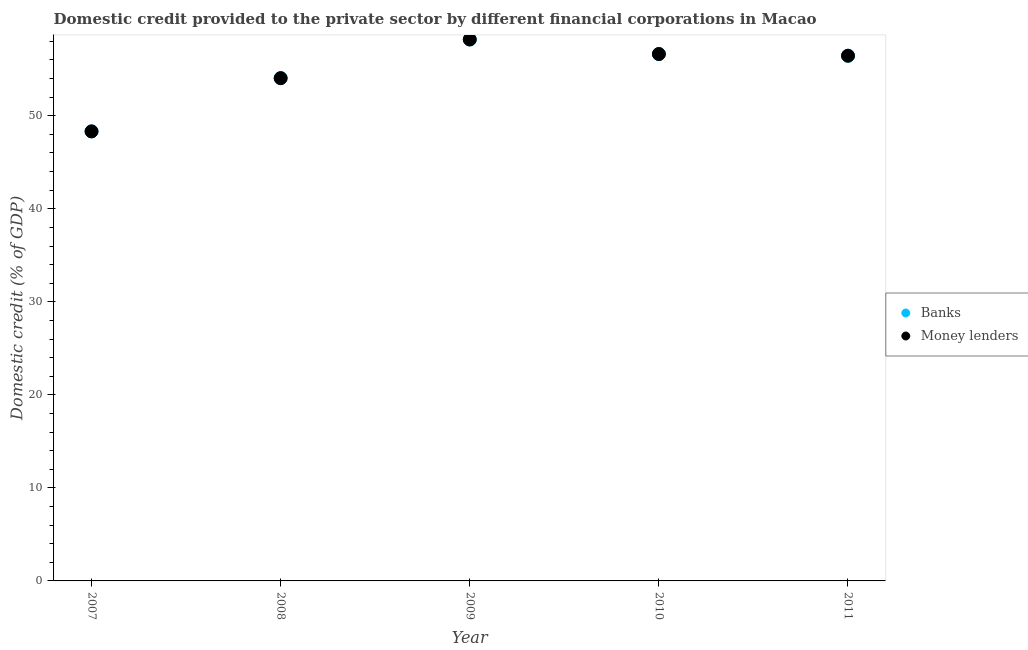How many different coloured dotlines are there?
Give a very brief answer. 2. What is the domestic credit provided by money lenders in 2009?
Your answer should be compact. 58.2. Across all years, what is the maximum domestic credit provided by banks?
Offer a terse response. 58.2. Across all years, what is the minimum domestic credit provided by banks?
Your response must be concise. 48.32. In which year was the domestic credit provided by money lenders maximum?
Offer a very short reply. 2009. In which year was the domestic credit provided by money lenders minimum?
Give a very brief answer. 2007. What is the total domestic credit provided by banks in the graph?
Offer a terse response. 273.65. What is the difference between the domestic credit provided by money lenders in 2007 and that in 2008?
Offer a very short reply. -5.72. What is the difference between the domestic credit provided by banks in 2011 and the domestic credit provided by money lenders in 2010?
Your answer should be very brief. -0.18. What is the average domestic credit provided by money lenders per year?
Provide a succinct answer. 54.73. What is the ratio of the domestic credit provided by banks in 2007 to that in 2008?
Provide a succinct answer. 0.89. What is the difference between the highest and the second highest domestic credit provided by money lenders?
Offer a very short reply. 1.57. What is the difference between the highest and the lowest domestic credit provided by banks?
Offer a terse response. 9.88. In how many years, is the domestic credit provided by banks greater than the average domestic credit provided by banks taken over all years?
Give a very brief answer. 3. Is the sum of the domestic credit provided by banks in 2007 and 2010 greater than the maximum domestic credit provided by money lenders across all years?
Offer a terse response. Yes. Does the domestic credit provided by money lenders monotonically increase over the years?
Offer a terse response. No. Is the domestic credit provided by money lenders strictly less than the domestic credit provided by banks over the years?
Give a very brief answer. No. Are the values on the major ticks of Y-axis written in scientific E-notation?
Offer a very short reply. No. How many legend labels are there?
Provide a succinct answer. 2. What is the title of the graph?
Your answer should be compact. Domestic credit provided to the private sector by different financial corporations in Macao. Does "Non-solid fuel" appear as one of the legend labels in the graph?
Ensure brevity in your answer.  No. What is the label or title of the X-axis?
Your response must be concise. Year. What is the label or title of the Y-axis?
Your response must be concise. Domestic credit (% of GDP). What is the Domestic credit (% of GDP) in Banks in 2007?
Provide a succinct answer. 48.32. What is the Domestic credit (% of GDP) of Money lenders in 2007?
Your answer should be compact. 48.32. What is the Domestic credit (% of GDP) of Banks in 2008?
Your answer should be very brief. 54.04. What is the Domestic credit (% of GDP) in Money lenders in 2008?
Provide a short and direct response. 54.04. What is the Domestic credit (% of GDP) in Banks in 2009?
Your response must be concise. 58.2. What is the Domestic credit (% of GDP) of Money lenders in 2009?
Your response must be concise. 58.2. What is the Domestic credit (% of GDP) in Banks in 2010?
Offer a terse response. 56.63. What is the Domestic credit (% of GDP) of Money lenders in 2010?
Your answer should be compact. 56.63. What is the Domestic credit (% of GDP) in Banks in 2011?
Your answer should be very brief. 56.45. What is the Domestic credit (% of GDP) of Money lenders in 2011?
Your answer should be very brief. 56.45. Across all years, what is the maximum Domestic credit (% of GDP) in Banks?
Ensure brevity in your answer.  58.2. Across all years, what is the maximum Domestic credit (% of GDP) of Money lenders?
Offer a terse response. 58.2. Across all years, what is the minimum Domestic credit (% of GDP) in Banks?
Keep it short and to the point. 48.32. Across all years, what is the minimum Domestic credit (% of GDP) of Money lenders?
Offer a terse response. 48.32. What is the total Domestic credit (% of GDP) in Banks in the graph?
Your answer should be compact. 273.65. What is the total Domestic credit (% of GDP) in Money lenders in the graph?
Offer a terse response. 273.65. What is the difference between the Domestic credit (% of GDP) of Banks in 2007 and that in 2008?
Your response must be concise. -5.72. What is the difference between the Domestic credit (% of GDP) of Money lenders in 2007 and that in 2008?
Offer a very short reply. -5.72. What is the difference between the Domestic credit (% of GDP) in Banks in 2007 and that in 2009?
Offer a terse response. -9.88. What is the difference between the Domestic credit (% of GDP) in Money lenders in 2007 and that in 2009?
Your response must be concise. -9.88. What is the difference between the Domestic credit (% of GDP) in Banks in 2007 and that in 2010?
Your answer should be very brief. -8.31. What is the difference between the Domestic credit (% of GDP) of Money lenders in 2007 and that in 2010?
Provide a succinct answer. -8.31. What is the difference between the Domestic credit (% of GDP) in Banks in 2007 and that in 2011?
Provide a short and direct response. -8.13. What is the difference between the Domestic credit (% of GDP) in Money lenders in 2007 and that in 2011?
Your response must be concise. -8.13. What is the difference between the Domestic credit (% of GDP) of Banks in 2008 and that in 2009?
Ensure brevity in your answer.  -4.16. What is the difference between the Domestic credit (% of GDP) in Money lenders in 2008 and that in 2009?
Give a very brief answer. -4.16. What is the difference between the Domestic credit (% of GDP) of Banks in 2008 and that in 2010?
Provide a short and direct response. -2.59. What is the difference between the Domestic credit (% of GDP) of Money lenders in 2008 and that in 2010?
Your answer should be very brief. -2.59. What is the difference between the Domestic credit (% of GDP) in Banks in 2008 and that in 2011?
Offer a terse response. -2.41. What is the difference between the Domestic credit (% of GDP) in Money lenders in 2008 and that in 2011?
Offer a very short reply. -2.41. What is the difference between the Domestic credit (% of GDP) of Banks in 2009 and that in 2010?
Ensure brevity in your answer.  1.57. What is the difference between the Domestic credit (% of GDP) of Money lenders in 2009 and that in 2010?
Your response must be concise. 1.57. What is the difference between the Domestic credit (% of GDP) of Banks in 2009 and that in 2011?
Make the answer very short. 1.75. What is the difference between the Domestic credit (% of GDP) in Money lenders in 2009 and that in 2011?
Provide a succinct answer. 1.75. What is the difference between the Domestic credit (% of GDP) in Banks in 2010 and that in 2011?
Offer a very short reply. 0.18. What is the difference between the Domestic credit (% of GDP) in Money lenders in 2010 and that in 2011?
Ensure brevity in your answer.  0.18. What is the difference between the Domestic credit (% of GDP) in Banks in 2007 and the Domestic credit (% of GDP) in Money lenders in 2008?
Your answer should be very brief. -5.72. What is the difference between the Domestic credit (% of GDP) of Banks in 2007 and the Domestic credit (% of GDP) of Money lenders in 2009?
Offer a terse response. -9.88. What is the difference between the Domestic credit (% of GDP) in Banks in 2007 and the Domestic credit (% of GDP) in Money lenders in 2010?
Provide a short and direct response. -8.31. What is the difference between the Domestic credit (% of GDP) of Banks in 2007 and the Domestic credit (% of GDP) of Money lenders in 2011?
Ensure brevity in your answer.  -8.13. What is the difference between the Domestic credit (% of GDP) of Banks in 2008 and the Domestic credit (% of GDP) of Money lenders in 2009?
Your response must be concise. -4.16. What is the difference between the Domestic credit (% of GDP) in Banks in 2008 and the Domestic credit (% of GDP) in Money lenders in 2010?
Offer a terse response. -2.59. What is the difference between the Domestic credit (% of GDP) of Banks in 2008 and the Domestic credit (% of GDP) of Money lenders in 2011?
Your answer should be compact. -2.41. What is the difference between the Domestic credit (% of GDP) in Banks in 2009 and the Domestic credit (% of GDP) in Money lenders in 2010?
Your response must be concise. 1.57. What is the difference between the Domestic credit (% of GDP) in Banks in 2009 and the Domestic credit (% of GDP) in Money lenders in 2011?
Provide a succinct answer. 1.75. What is the difference between the Domestic credit (% of GDP) of Banks in 2010 and the Domestic credit (% of GDP) of Money lenders in 2011?
Provide a short and direct response. 0.18. What is the average Domestic credit (% of GDP) in Banks per year?
Give a very brief answer. 54.73. What is the average Domestic credit (% of GDP) of Money lenders per year?
Ensure brevity in your answer.  54.73. In the year 2009, what is the difference between the Domestic credit (% of GDP) in Banks and Domestic credit (% of GDP) in Money lenders?
Your answer should be compact. 0. In the year 2010, what is the difference between the Domestic credit (% of GDP) in Banks and Domestic credit (% of GDP) in Money lenders?
Your answer should be compact. 0. What is the ratio of the Domestic credit (% of GDP) of Banks in 2007 to that in 2008?
Offer a terse response. 0.89. What is the ratio of the Domestic credit (% of GDP) in Money lenders in 2007 to that in 2008?
Provide a succinct answer. 0.89. What is the ratio of the Domestic credit (% of GDP) of Banks in 2007 to that in 2009?
Give a very brief answer. 0.83. What is the ratio of the Domestic credit (% of GDP) of Money lenders in 2007 to that in 2009?
Give a very brief answer. 0.83. What is the ratio of the Domestic credit (% of GDP) in Banks in 2007 to that in 2010?
Offer a terse response. 0.85. What is the ratio of the Domestic credit (% of GDP) in Money lenders in 2007 to that in 2010?
Make the answer very short. 0.85. What is the ratio of the Domestic credit (% of GDP) of Banks in 2007 to that in 2011?
Make the answer very short. 0.86. What is the ratio of the Domestic credit (% of GDP) of Money lenders in 2007 to that in 2011?
Your response must be concise. 0.86. What is the ratio of the Domestic credit (% of GDP) in Banks in 2008 to that in 2009?
Offer a terse response. 0.93. What is the ratio of the Domestic credit (% of GDP) in Money lenders in 2008 to that in 2009?
Make the answer very short. 0.93. What is the ratio of the Domestic credit (% of GDP) of Banks in 2008 to that in 2010?
Offer a very short reply. 0.95. What is the ratio of the Domestic credit (% of GDP) in Money lenders in 2008 to that in 2010?
Provide a short and direct response. 0.95. What is the ratio of the Domestic credit (% of GDP) in Banks in 2008 to that in 2011?
Your answer should be very brief. 0.96. What is the ratio of the Domestic credit (% of GDP) in Money lenders in 2008 to that in 2011?
Give a very brief answer. 0.96. What is the ratio of the Domestic credit (% of GDP) in Banks in 2009 to that in 2010?
Ensure brevity in your answer.  1.03. What is the ratio of the Domestic credit (% of GDP) of Money lenders in 2009 to that in 2010?
Give a very brief answer. 1.03. What is the ratio of the Domestic credit (% of GDP) of Banks in 2009 to that in 2011?
Give a very brief answer. 1.03. What is the ratio of the Domestic credit (% of GDP) of Money lenders in 2009 to that in 2011?
Keep it short and to the point. 1.03. What is the ratio of the Domestic credit (% of GDP) in Banks in 2010 to that in 2011?
Ensure brevity in your answer.  1. What is the difference between the highest and the second highest Domestic credit (% of GDP) in Banks?
Your answer should be compact. 1.57. What is the difference between the highest and the second highest Domestic credit (% of GDP) of Money lenders?
Make the answer very short. 1.57. What is the difference between the highest and the lowest Domestic credit (% of GDP) in Banks?
Provide a succinct answer. 9.88. What is the difference between the highest and the lowest Domestic credit (% of GDP) in Money lenders?
Provide a succinct answer. 9.88. 